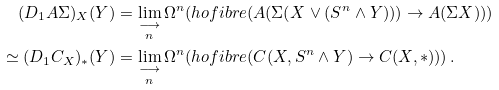Convert formula to latex. <formula><loc_0><loc_0><loc_500><loc_500>( D _ { 1 } A \Sigma ) _ { X } ( Y ) & = \underset { n } { \underset { \longrightarrow } { \lim } } \, \Omega ^ { n } ( h o f i b r e ( A ( \Sigma ( X \vee ( S ^ { n } \wedge Y ) ) ) \to A ( \Sigma X ) ) ) \\ \simeq ( D _ { 1 } C _ { X } ) _ { * } ( Y ) & = \underset { n } { \underset { \longrightarrow } { \lim } } \, \Omega ^ { n } ( h o f i b r e ( C ( X , S ^ { n } \wedge Y ) \to C ( X , * ) ) ) \, .</formula> 